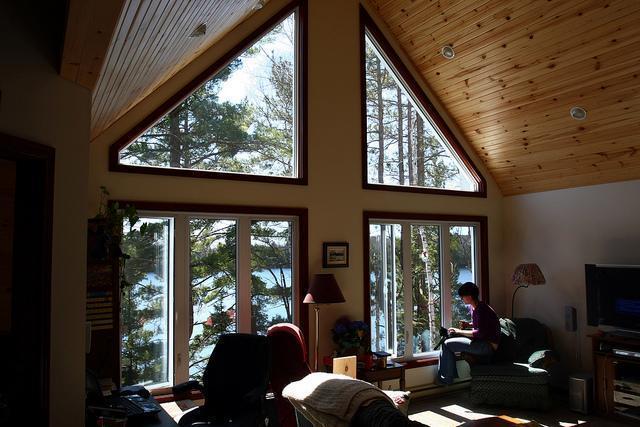How many windows do you see?
Give a very brief answer. 4. How many chairs are in the picture?
Give a very brief answer. 4. How many plates have a sandwich on it?
Give a very brief answer. 0. 